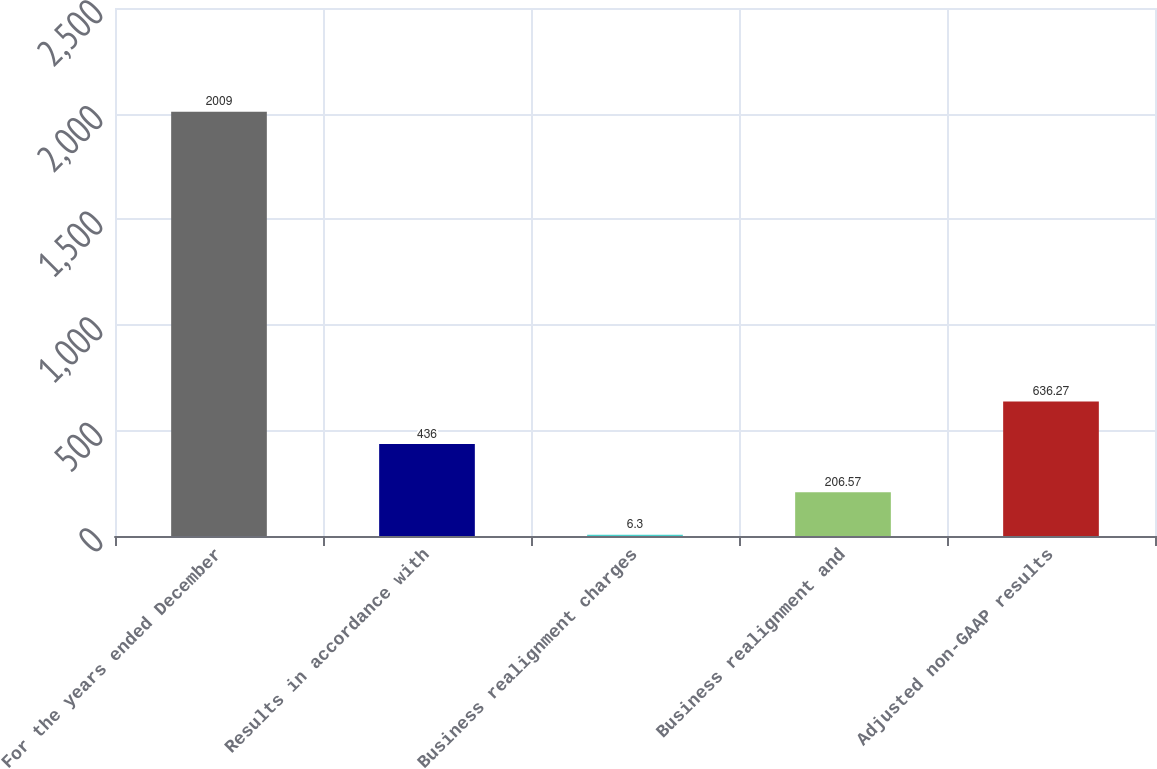Convert chart to OTSL. <chart><loc_0><loc_0><loc_500><loc_500><bar_chart><fcel>For the years ended December<fcel>Results in accordance with<fcel>Business realignment charges<fcel>Business realignment and<fcel>Adjusted non-GAAP results<nl><fcel>2009<fcel>436<fcel>6.3<fcel>206.57<fcel>636.27<nl></chart> 